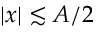Convert formula to latex. <formula><loc_0><loc_0><loc_500><loc_500>| x | \lesssim A / 2</formula> 